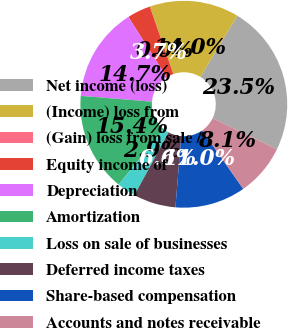Convert chart. <chart><loc_0><loc_0><loc_500><loc_500><pie_chart><fcel>Net income (loss)<fcel>(Income) loss from<fcel>(Gain) loss from sale /<fcel>Equity income of<fcel>Depreciation<fcel>Amortization<fcel>Loss on sale of businesses<fcel>Deferred income taxes<fcel>Share-based compensation<fcel>Accounts and notes receivable<nl><fcel>23.52%<fcel>13.97%<fcel>0.01%<fcel>3.68%<fcel>14.7%<fcel>15.44%<fcel>2.94%<fcel>6.62%<fcel>11.03%<fcel>8.09%<nl></chart> 